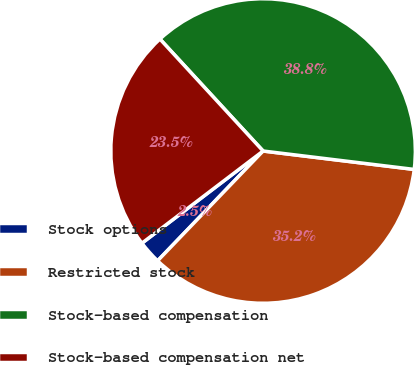<chart> <loc_0><loc_0><loc_500><loc_500><pie_chart><fcel>Stock options<fcel>Restricted stock<fcel>Stock-based compensation<fcel>Stock-based compensation net<nl><fcel>2.47%<fcel>35.25%<fcel>38.78%<fcel>23.5%<nl></chart> 